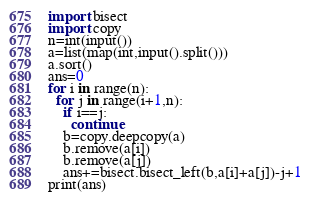Convert code to text. <code><loc_0><loc_0><loc_500><loc_500><_Python_>import bisect
import copy
n=int(input())
a=list(map(int,input().split()))
a.sort()
ans=0
for i in range(n):
  for j in range(i+1,n):
    if i==j:
      continue
    b=copy.deepcopy(a)
    b.remove(a[i])
    b.remove(a[j])
    ans+=bisect.bisect_left(b,a[i]+a[j])-j+1
print(ans)</code> 